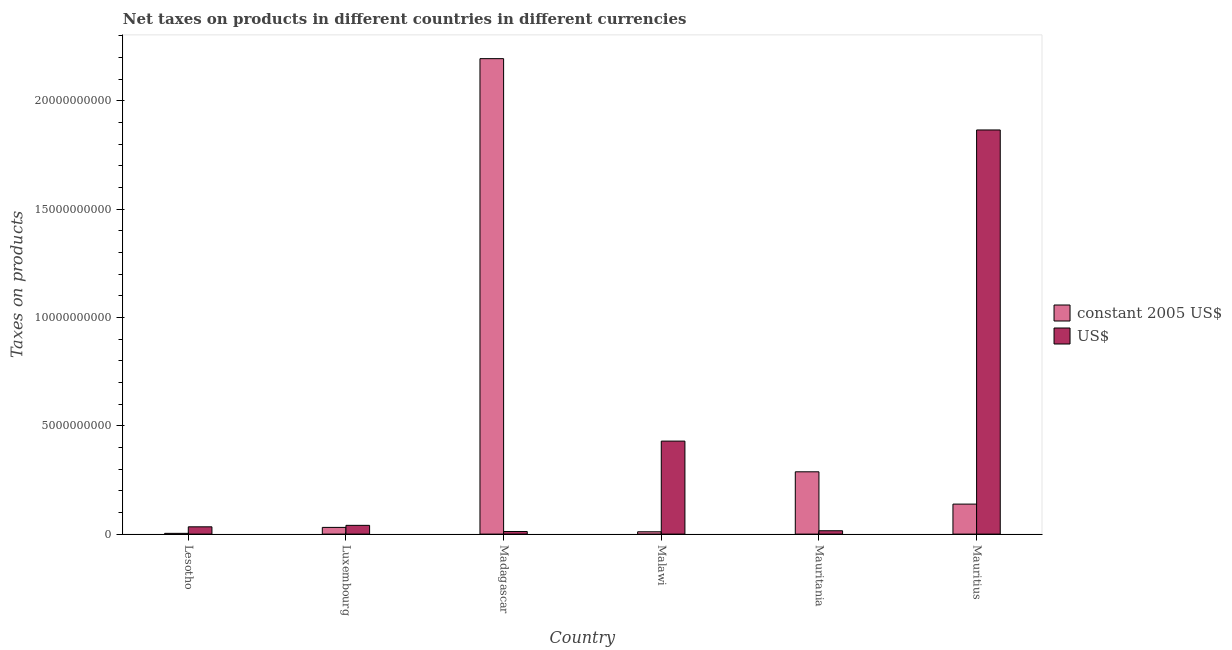How many groups of bars are there?
Offer a very short reply. 6. Are the number of bars on each tick of the X-axis equal?
Offer a very short reply. Yes. What is the label of the 4th group of bars from the left?
Keep it short and to the point. Malawi. What is the net taxes in constant 2005 us$ in Malawi?
Your response must be concise. 1.08e+08. Across all countries, what is the maximum net taxes in us$?
Keep it short and to the point. 1.87e+1. Across all countries, what is the minimum net taxes in us$?
Give a very brief answer. 1.20e+08. In which country was the net taxes in us$ maximum?
Your answer should be very brief. Mauritius. In which country was the net taxes in us$ minimum?
Give a very brief answer. Madagascar. What is the total net taxes in constant 2005 us$ in the graph?
Your answer should be very brief. 2.67e+1. What is the difference between the net taxes in us$ in Madagascar and that in Mauritius?
Keep it short and to the point. -1.85e+1. What is the difference between the net taxes in constant 2005 us$ in Mauritania and the net taxes in us$ in Luxembourg?
Offer a very short reply. 2.47e+09. What is the average net taxes in constant 2005 us$ per country?
Provide a short and direct response. 4.44e+09. What is the difference between the net taxes in constant 2005 us$ and net taxes in us$ in Malawi?
Your answer should be compact. -4.18e+09. What is the ratio of the net taxes in constant 2005 us$ in Lesotho to that in Luxembourg?
Your response must be concise. 0.11. What is the difference between the highest and the second highest net taxes in us$?
Make the answer very short. 1.44e+1. What is the difference between the highest and the lowest net taxes in us$?
Offer a terse response. 1.85e+1. Is the sum of the net taxes in constant 2005 us$ in Mauritania and Mauritius greater than the maximum net taxes in us$ across all countries?
Provide a succinct answer. No. What does the 2nd bar from the left in Madagascar represents?
Provide a succinct answer. US$. What does the 1st bar from the right in Lesotho represents?
Give a very brief answer. US$. How many bars are there?
Keep it short and to the point. 12. Are all the bars in the graph horizontal?
Ensure brevity in your answer.  No. Does the graph contain any zero values?
Your response must be concise. No. Does the graph contain grids?
Your answer should be very brief. No. Where does the legend appear in the graph?
Keep it short and to the point. Center right. How many legend labels are there?
Ensure brevity in your answer.  2. What is the title of the graph?
Offer a very short reply. Net taxes on products in different countries in different currencies. What is the label or title of the X-axis?
Give a very brief answer. Country. What is the label or title of the Y-axis?
Give a very brief answer. Taxes on products. What is the Taxes on products in constant 2005 US$ in Lesotho?
Ensure brevity in your answer.  3.50e+07. What is the Taxes on products of US$ in Lesotho?
Make the answer very short. 3.36e+08. What is the Taxes on products of constant 2005 US$ in Luxembourg?
Give a very brief answer. 3.10e+08. What is the Taxes on products of US$ in Luxembourg?
Offer a very short reply. 4.04e+08. What is the Taxes on products of constant 2005 US$ in Madagascar?
Offer a very short reply. 2.19e+1. What is the Taxes on products of US$ in Madagascar?
Your answer should be very brief. 1.20e+08. What is the Taxes on products in constant 2005 US$ in Malawi?
Offer a terse response. 1.08e+08. What is the Taxes on products in US$ in Malawi?
Provide a succinct answer. 4.29e+09. What is the Taxes on products in constant 2005 US$ in Mauritania?
Provide a short and direct response. 2.88e+09. What is the Taxes on products in US$ in Mauritania?
Provide a succinct answer. 1.55e+08. What is the Taxes on products of constant 2005 US$ in Mauritius?
Give a very brief answer. 1.38e+09. What is the Taxes on products of US$ in Mauritius?
Provide a succinct answer. 1.87e+1. Across all countries, what is the maximum Taxes on products of constant 2005 US$?
Offer a terse response. 2.19e+1. Across all countries, what is the maximum Taxes on products in US$?
Make the answer very short. 1.87e+1. Across all countries, what is the minimum Taxes on products of constant 2005 US$?
Provide a succinct answer. 3.50e+07. Across all countries, what is the minimum Taxes on products of US$?
Provide a succinct answer. 1.20e+08. What is the total Taxes on products of constant 2005 US$ in the graph?
Provide a succinct answer. 2.67e+1. What is the total Taxes on products in US$ in the graph?
Provide a short and direct response. 2.40e+1. What is the difference between the Taxes on products of constant 2005 US$ in Lesotho and that in Luxembourg?
Your answer should be very brief. -2.75e+08. What is the difference between the Taxes on products in US$ in Lesotho and that in Luxembourg?
Ensure brevity in your answer.  -6.73e+07. What is the difference between the Taxes on products of constant 2005 US$ in Lesotho and that in Madagascar?
Make the answer very short. -2.19e+1. What is the difference between the Taxes on products in US$ in Lesotho and that in Madagascar?
Offer a very short reply. 2.16e+08. What is the difference between the Taxes on products of constant 2005 US$ in Lesotho and that in Malawi?
Your answer should be compact. -7.28e+07. What is the difference between the Taxes on products of US$ in Lesotho and that in Malawi?
Your answer should be very brief. -3.96e+09. What is the difference between the Taxes on products in constant 2005 US$ in Lesotho and that in Mauritania?
Your response must be concise. -2.84e+09. What is the difference between the Taxes on products in US$ in Lesotho and that in Mauritania?
Keep it short and to the point. 1.82e+08. What is the difference between the Taxes on products in constant 2005 US$ in Lesotho and that in Mauritius?
Ensure brevity in your answer.  -1.35e+09. What is the difference between the Taxes on products of US$ in Lesotho and that in Mauritius?
Ensure brevity in your answer.  -1.83e+1. What is the difference between the Taxes on products of constant 2005 US$ in Luxembourg and that in Madagascar?
Keep it short and to the point. -2.16e+1. What is the difference between the Taxes on products of US$ in Luxembourg and that in Madagascar?
Provide a short and direct response. 2.83e+08. What is the difference between the Taxes on products in constant 2005 US$ in Luxembourg and that in Malawi?
Give a very brief answer. 2.02e+08. What is the difference between the Taxes on products in US$ in Luxembourg and that in Malawi?
Provide a short and direct response. -3.89e+09. What is the difference between the Taxes on products in constant 2005 US$ in Luxembourg and that in Mauritania?
Make the answer very short. -2.57e+09. What is the difference between the Taxes on products of US$ in Luxembourg and that in Mauritania?
Your answer should be compact. 2.49e+08. What is the difference between the Taxes on products of constant 2005 US$ in Luxembourg and that in Mauritius?
Make the answer very short. -1.08e+09. What is the difference between the Taxes on products of US$ in Luxembourg and that in Mauritius?
Offer a very short reply. -1.82e+1. What is the difference between the Taxes on products in constant 2005 US$ in Madagascar and that in Malawi?
Offer a very short reply. 2.18e+1. What is the difference between the Taxes on products in US$ in Madagascar and that in Malawi?
Your response must be concise. -4.17e+09. What is the difference between the Taxes on products in constant 2005 US$ in Madagascar and that in Mauritania?
Your answer should be compact. 1.91e+1. What is the difference between the Taxes on products in US$ in Madagascar and that in Mauritania?
Ensure brevity in your answer.  -3.45e+07. What is the difference between the Taxes on products of constant 2005 US$ in Madagascar and that in Mauritius?
Offer a terse response. 2.06e+1. What is the difference between the Taxes on products of US$ in Madagascar and that in Mauritius?
Ensure brevity in your answer.  -1.85e+1. What is the difference between the Taxes on products in constant 2005 US$ in Malawi and that in Mauritania?
Keep it short and to the point. -2.77e+09. What is the difference between the Taxes on products of US$ in Malawi and that in Mauritania?
Your answer should be compact. 4.14e+09. What is the difference between the Taxes on products in constant 2005 US$ in Malawi and that in Mauritius?
Give a very brief answer. -1.28e+09. What is the difference between the Taxes on products in US$ in Malawi and that in Mauritius?
Your answer should be compact. -1.44e+1. What is the difference between the Taxes on products in constant 2005 US$ in Mauritania and that in Mauritius?
Offer a terse response. 1.49e+09. What is the difference between the Taxes on products of US$ in Mauritania and that in Mauritius?
Your answer should be compact. -1.85e+1. What is the difference between the Taxes on products of constant 2005 US$ in Lesotho and the Taxes on products of US$ in Luxembourg?
Provide a succinct answer. -3.69e+08. What is the difference between the Taxes on products in constant 2005 US$ in Lesotho and the Taxes on products in US$ in Madagascar?
Make the answer very short. -8.54e+07. What is the difference between the Taxes on products in constant 2005 US$ in Lesotho and the Taxes on products in US$ in Malawi?
Provide a short and direct response. -4.26e+09. What is the difference between the Taxes on products in constant 2005 US$ in Lesotho and the Taxes on products in US$ in Mauritania?
Offer a terse response. -1.20e+08. What is the difference between the Taxes on products of constant 2005 US$ in Lesotho and the Taxes on products of US$ in Mauritius?
Give a very brief answer. -1.86e+1. What is the difference between the Taxes on products in constant 2005 US$ in Luxembourg and the Taxes on products in US$ in Madagascar?
Ensure brevity in your answer.  1.89e+08. What is the difference between the Taxes on products in constant 2005 US$ in Luxembourg and the Taxes on products in US$ in Malawi?
Give a very brief answer. -3.98e+09. What is the difference between the Taxes on products in constant 2005 US$ in Luxembourg and the Taxes on products in US$ in Mauritania?
Give a very brief answer. 1.55e+08. What is the difference between the Taxes on products of constant 2005 US$ in Luxembourg and the Taxes on products of US$ in Mauritius?
Provide a succinct answer. -1.83e+1. What is the difference between the Taxes on products of constant 2005 US$ in Madagascar and the Taxes on products of US$ in Malawi?
Provide a short and direct response. 1.77e+1. What is the difference between the Taxes on products in constant 2005 US$ in Madagascar and the Taxes on products in US$ in Mauritania?
Offer a very short reply. 2.18e+1. What is the difference between the Taxes on products of constant 2005 US$ in Madagascar and the Taxes on products of US$ in Mauritius?
Your answer should be compact. 3.29e+09. What is the difference between the Taxes on products of constant 2005 US$ in Malawi and the Taxes on products of US$ in Mauritania?
Give a very brief answer. -4.72e+07. What is the difference between the Taxes on products of constant 2005 US$ in Malawi and the Taxes on products of US$ in Mauritius?
Give a very brief answer. -1.85e+1. What is the difference between the Taxes on products in constant 2005 US$ in Mauritania and the Taxes on products in US$ in Mauritius?
Your response must be concise. -1.58e+1. What is the average Taxes on products of constant 2005 US$ per country?
Your answer should be compact. 4.44e+09. What is the average Taxes on products in US$ per country?
Your response must be concise. 3.99e+09. What is the difference between the Taxes on products in constant 2005 US$ and Taxes on products in US$ in Lesotho?
Keep it short and to the point. -3.01e+08. What is the difference between the Taxes on products in constant 2005 US$ and Taxes on products in US$ in Luxembourg?
Your answer should be compact. -9.41e+07. What is the difference between the Taxes on products of constant 2005 US$ and Taxes on products of US$ in Madagascar?
Your answer should be very brief. 2.18e+1. What is the difference between the Taxes on products in constant 2005 US$ and Taxes on products in US$ in Malawi?
Offer a very short reply. -4.18e+09. What is the difference between the Taxes on products of constant 2005 US$ and Taxes on products of US$ in Mauritania?
Provide a short and direct response. 2.72e+09. What is the difference between the Taxes on products of constant 2005 US$ and Taxes on products of US$ in Mauritius?
Give a very brief answer. -1.73e+1. What is the ratio of the Taxes on products in constant 2005 US$ in Lesotho to that in Luxembourg?
Give a very brief answer. 0.11. What is the ratio of the Taxes on products of constant 2005 US$ in Lesotho to that in Madagascar?
Give a very brief answer. 0. What is the ratio of the Taxes on products in US$ in Lesotho to that in Madagascar?
Your response must be concise. 2.79. What is the ratio of the Taxes on products in constant 2005 US$ in Lesotho to that in Malawi?
Keep it short and to the point. 0.32. What is the ratio of the Taxes on products of US$ in Lesotho to that in Malawi?
Your answer should be compact. 0.08. What is the ratio of the Taxes on products of constant 2005 US$ in Lesotho to that in Mauritania?
Offer a very short reply. 0.01. What is the ratio of the Taxes on products of US$ in Lesotho to that in Mauritania?
Offer a very short reply. 2.17. What is the ratio of the Taxes on products in constant 2005 US$ in Lesotho to that in Mauritius?
Make the answer very short. 0.03. What is the ratio of the Taxes on products in US$ in Lesotho to that in Mauritius?
Offer a very short reply. 0.02. What is the ratio of the Taxes on products of constant 2005 US$ in Luxembourg to that in Madagascar?
Your response must be concise. 0.01. What is the ratio of the Taxes on products of US$ in Luxembourg to that in Madagascar?
Keep it short and to the point. 3.35. What is the ratio of the Taxes on products of constant 2005 US$ in Luxembourg to that in Malawi?
Ensure brevity in your answer.  2.87. What is the ratio of the Taxes on products in US$ in Luxembourg to that in Malawi?
Offer a terse response. 0.09. What is the ratio of the Taxes on products in constant 2005 US$ in Luxembourg to that in Mauritania?
Give a very brief answer. 0.11. What is the ratio of the Taxes on products in US$ in Luxembourg to that in Mauritania?
Provide a short and direct response. 2.61. What is the ratio of the Taxes on products in constant 2005 US$ in Luxembourg to that in Mauritius?
Your answer should be compact. 0.22. What is the ratio of the Taxes on products of US$ in Luxembourg to that in Mauritius?
Keep it short and to the point. 0.02. What is the ratio of the Taxes on products in constant 2005 US$ in Madagascar to that in Malawi?
Your answer should be compact. 203.56. What is the ratio of the Taxes on products in US$ in Madagascar to that in Malawi?
Offer a terse response. 0.03. What is the ratio of the Taxes on products of constant 2005 US$ in Madagascar to that in Mauritania?
Offer a terse response. 7.63. What is the ratio of the Taxes on products in US$ in Madagascar to that in Mauritania?
Keep it short and to the point. 0.78. What is the ratio of the Taxes on products in constant 2005 US$ in Madagascar to that in Mauritius?
Ensure brevity in your answer.  15.85. What is the ratio of the Taxes on products of US$ in Madagascar to that in Mauritius?
Give a very brief answer. 0.01. What is the ratio of the Taxes on products of constant 2005 US$ in Malawi to that in Mauritania?
Your response must be concise. 0.04. What is the ratio of the Taxes on products of US$ in Malawi to that in Mauritania?
Keep it short and to the point. 27.7. What is the ratio of the Taxes on products of constant 2005 US$ in Malawi to that in Mauritius?
Your response must be concise. 0.08. What is the ratio of the Taxes on products in US$ in Malawi to that in Mauritius?
Make the answer very short. 0.23. What is the ratio of the Taxes on products of constant 2005 US$ in Mauritania to that in Mauritius?
Offer a terse response. 2.08. What is the ratio of the Taxes on products of US$ in Mauritania to that in Mauritius?
Your answer should be very brief. 0.01. What is the difference between the highest and the second highest Taxes on products in constant 2005 US$?
Offer a very short reply. 1.91e+1. What is the difference between the highest and the second highest Taxes on products of US$?
Provide a short and direct response. 1.44e+1. What is the difference between the highest and the lowest Taxes on products in constant 2005 US$?
Your answer should be compact. 2.19e+1. What is the difference between the highest and the lowest Taxes on products of US$?
Your answer should be very brief. 1.85e+1. 